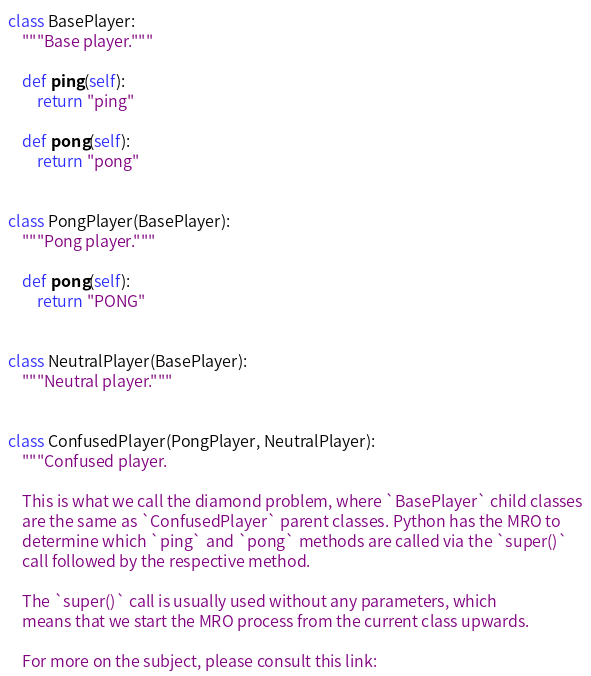Convert code to text. <code><loc_0><loc_0><loc_500><loc_500><_Python_>class BasePlayer:
    """Base player."""

    def ping(self):
        return "ping"

    def pong(self):
        return "pong"


class PongPlayer(BasePlayer):
    """Pong player."""

    def pong(self):
        return "PONG"


class NeutralPlayer(BasePlayer):
    """Neutral player."""


class ConfusedPlayer(PongPlayer, NeutralPlayer):
    """Confused player.

    This is what we call the diamond problem, where `BasePlayer` child classes
    are the same as `ConfusedPlayer` parent classes. Python has the MRO to
    determine which `ping` and `pong` methods are called via the `super()`
    call followed by the respective method.

    The `super()` call is usually used without any parameters, which
    means that we start the MRO process from the current class upwards.

    For more on the subject, please consult this link:
</code> 